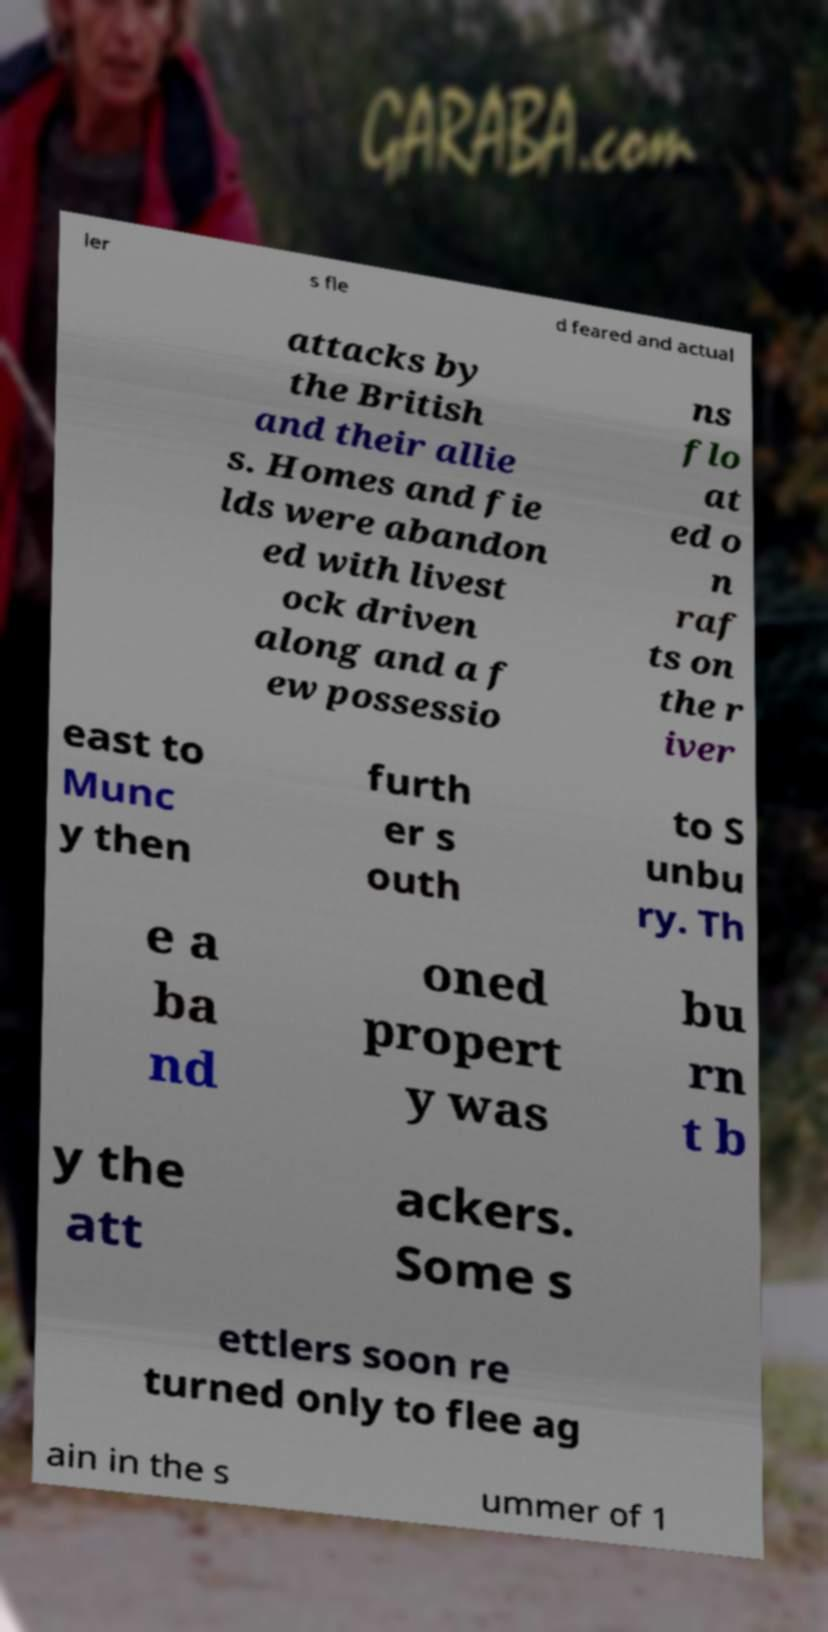Could you extract and type out the text from this image? ler s fle d feared and actual attacks by the British and their allie s. Homes and fie lds were abandon ed with livest ock driven along and a f ew possessio ns flo at ed o n raf ts on the r iver east to Munc y then furth er s outh to S unbu ry. Th e a ba nd oned propert y was bu rn t b y the att ackers. Some s ettlers soon re turned only to flee ag ain in the s ummer of 1 